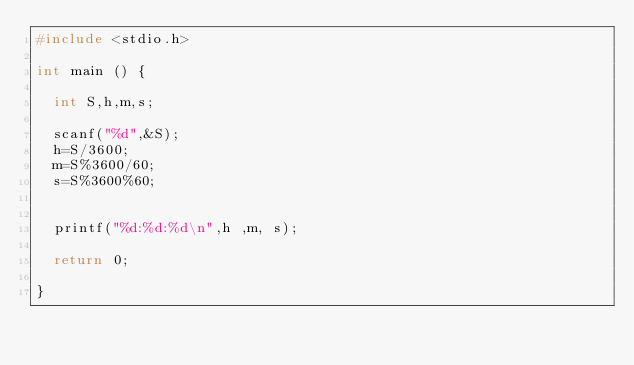Convert code to text. <code><loc_0><loc_0><loc_500><loc_500><_C_>#include <stdio.h>

int main () {

  int S,h,m,s;

  scanf("%d",&S);
  h=S/3600;
  m=S%3600/60;
  s=S%3600%60;
  
  
  printf("%d:%d:%d\n",h ,m, s);

  return 0;

}

  </code> 